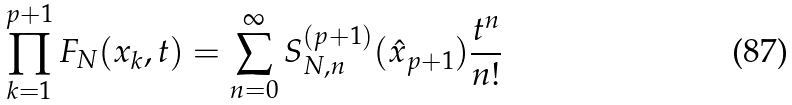<formula> <loc_0><loc_0><loc_500><loc_500>\prod _ { k = 1 } ^ { p + 1 } F _ { N } ( x _ { k } , t ) = \sum _ { n = 0 } ^ { \infty } S _ { N , n } ^ { ( p + 1 ) } ( \hat { x } _ { p + 1 } ) \frac { t ^ { n } } { n ! }</formula> 